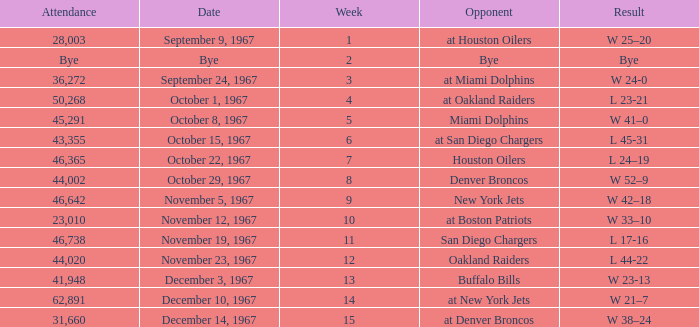What was the date of the game after week 5 against the Houston Oilers? October 22, 1967. 